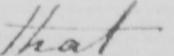Can you read and transcribe this handwriting? that 